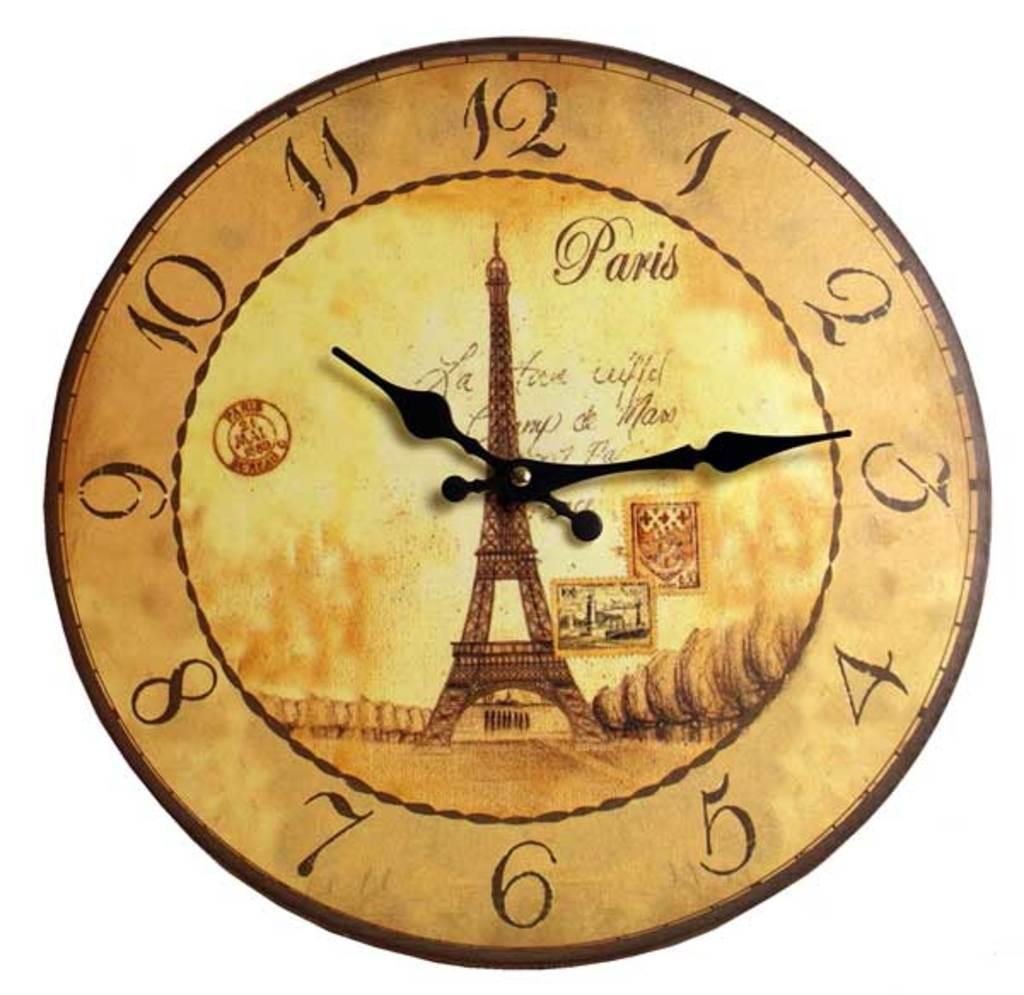What time is it?
Give a very brief answer. 10:14. 